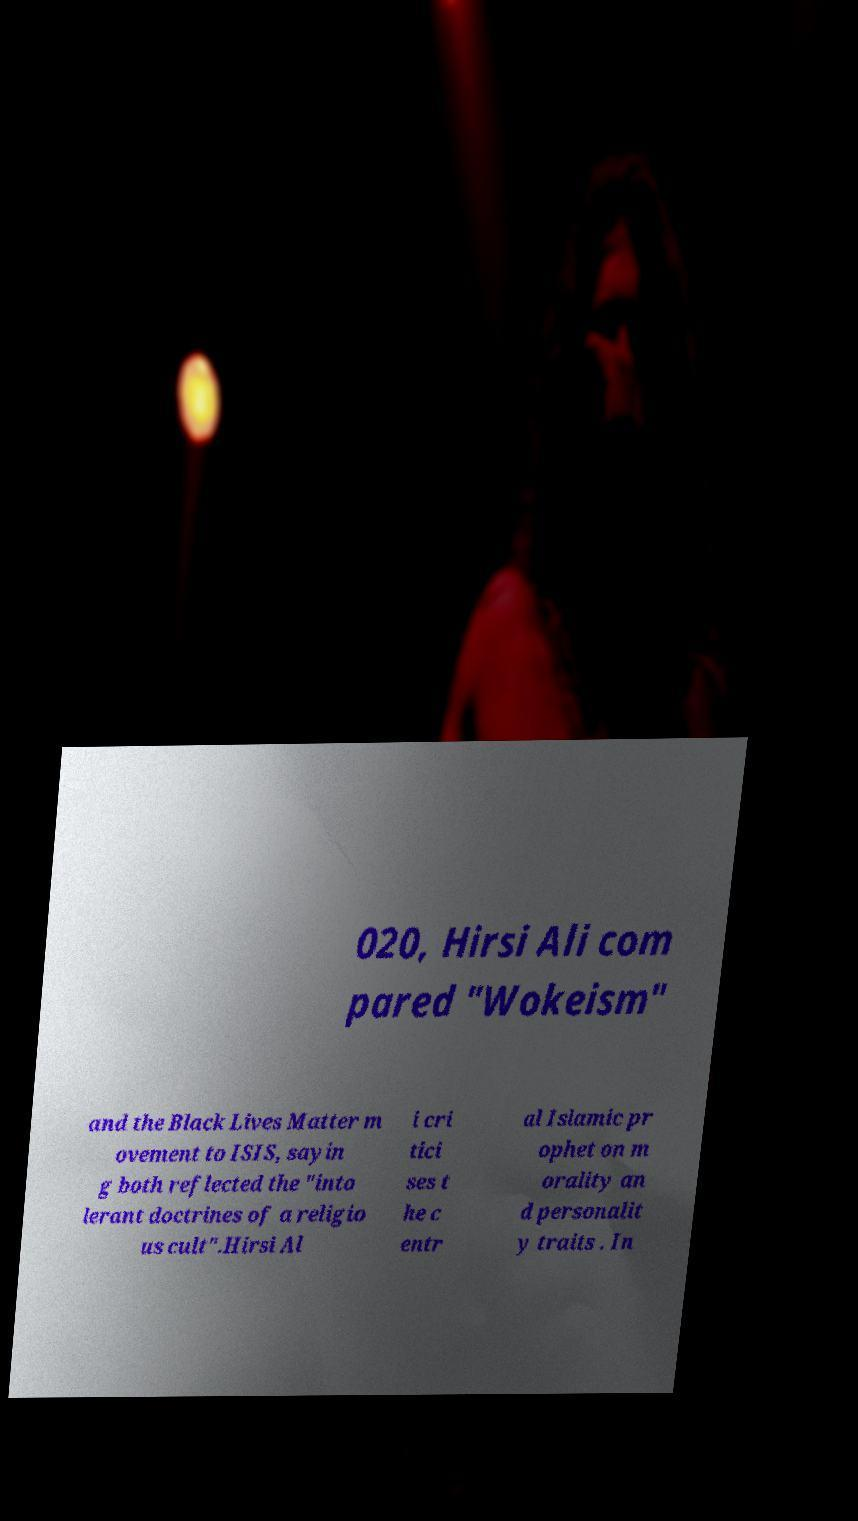Can you accurately transcribe the text from the provided image for me? 020, Hirsi Ali com pared "Wokeism" and the Black Lives Matter m ovement to ISIS, sayin g both reflected the "into lerant doctrines of a religio us cult".Hirsi Al i cri tici ses t he c entr al Islamic pr ophet on m orality an d personalit y traits . In 